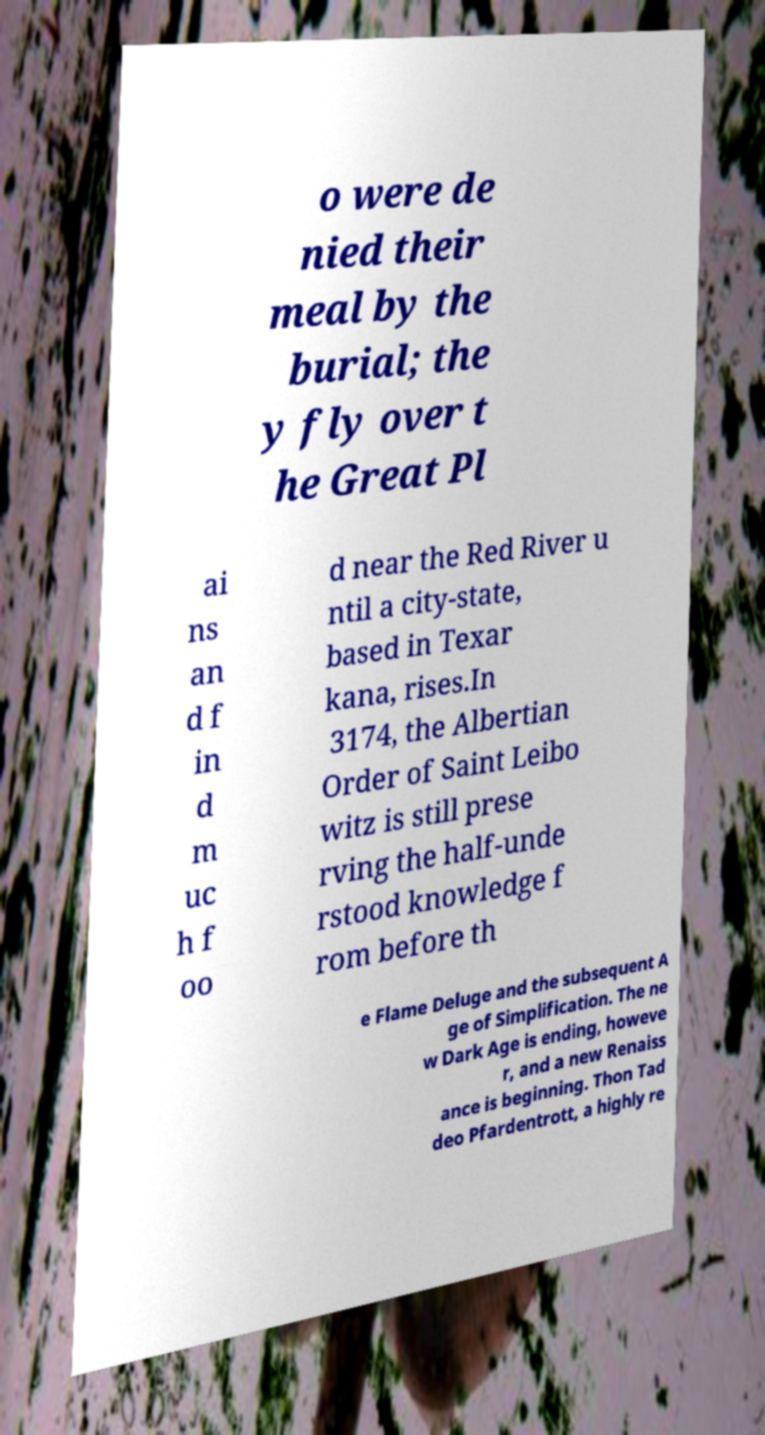There's text embedded in this image that I need extracted. Can you transcribe it verbatim? o were de nied their meal by the burial; the y fly over t he Great Pl ai ns an d f in d m uc h f oo d near the Red River u ntil a city-state, based in Texar kana, rises.In 3174, the Albertian Order of Saint Leibo witz is still prese rving the half-unde rstood knowledge f rom before th e Flame Deluge and the subsequent A ge of Simplification. The ne w Dark Age is ending, howeve r, and a new Renaiss ance is beginning. Thon Tad deo Pfardentrott, a highly re 